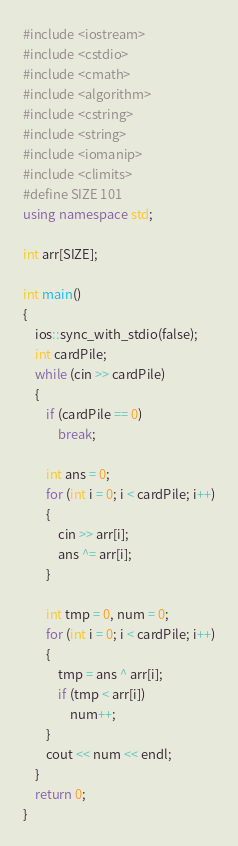Convert code to text. <code><loc_0><loc_0><loc_500><loc_500><_C++_>#include <iostream>
#include <cstdio>
#include <cmath>
#include <algorithm>
#include <cstring>
#include <string>
#include <iomanip>
#include <climits>
#define SIZE 101
using namespace std;

int arr[SIZE];

int main()
{
    ios::sync_with_stdio(false);
    int cardPile;
    while (cin >> cardPile)
    {
        if (cardPile == 0)
            break;

        int ans = 0;
        for (int i = 0; i < cardPile; i++)
        {
            cin >> arr[i];
            ans ^= arr[i];
        }

        int tmp = 0, num = 0;
        for (int i = 0; i < cardPile; i++)
        {
            tmp = ans ^ arr[i];
            if (tmp < arr[i])
                num++;
        }
        cout << num << endl;
    }
    return 0;
}
</code> 